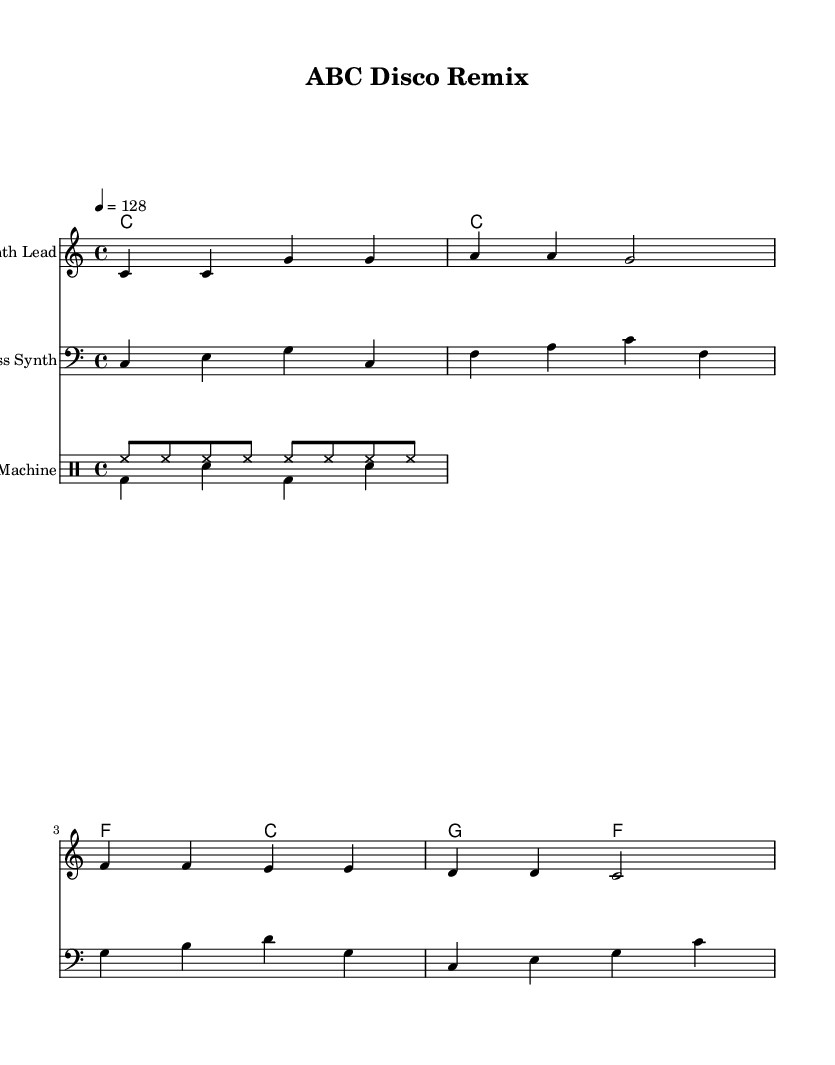What is the key signature of this music? The key signature is C major, which has no sharps or flats.
Answer: C major What is the time signature of this music? The time signature is indicated at the beginning as 4/4, meaning four beats per measure.
Answer: 4/4 What is the tempo marking in this piece? The tempo marking shows "4 = 128", meaning there are 128 beats per minute.
Answer: 128 How many measures are in the melody section? Counting the measures in the melody section, there are four measures in total.
Answer: 4 Which instrument plays the bass line? The bass line is played by the instrument designated as "Bass Synth" in the sheet music.
Answer: Bass Synth What type of rhythm is used in the drum pattern? The drum pattern consists of eighth notes for the hi-hat and a combination of kick and snare for the beat, typical in house music.
Answer: House rhythm What is the harmonic progression in the second half of the piece? The harmonic progression in the second half consists of F to C, followed by G to F, commonly found in disco house remixes.
Answer: F to C, G to F 